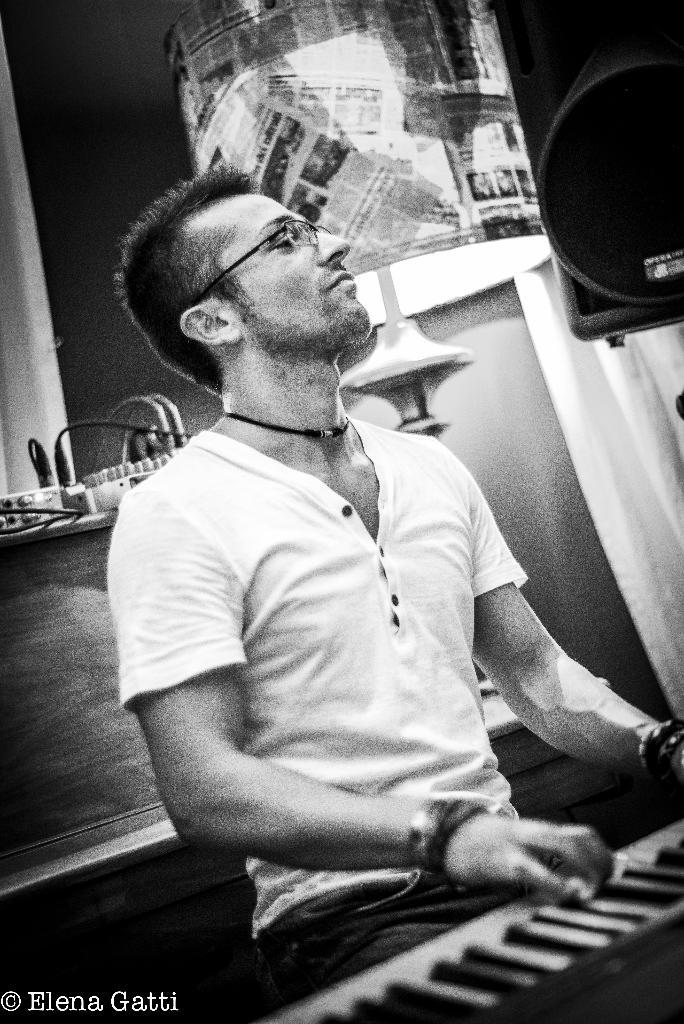Who is the person in the image? There is a man in the image. What is the man doing in the image? The man is sitting in the image. What object is in front of the man? The man is in front of a keyboard. What can be seen in the background of the image? There is a lamp and some equipment in the background of the image. What is the name of the ice that is present in the image? There is no ice present in the image. Can you join the man and the equipment in the image? It is not possible to join the man and the equipment in the image, as it is a static representation. 